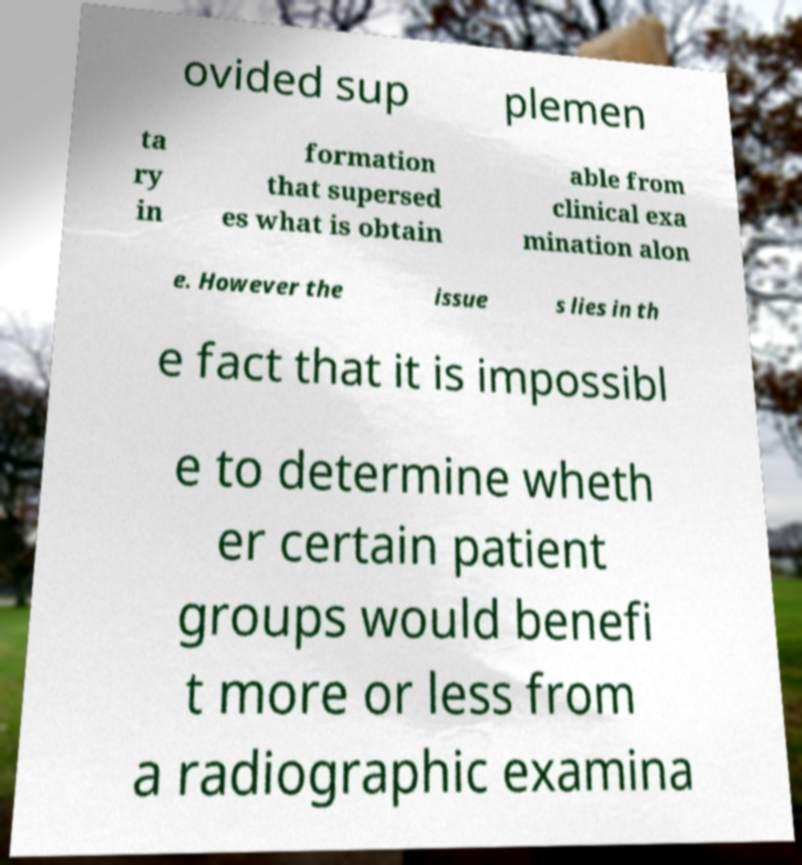Could you assist in decoding the text presented in this image and type it out clearly? ovided sup plemen ta ry in formation that supersed es what is obtain able from clinical exa mination alon e. However the issue s lies in th e fact that it is impossibl e to determine wheth er certain patient groups would benefi t more or less from a radiographic examina 